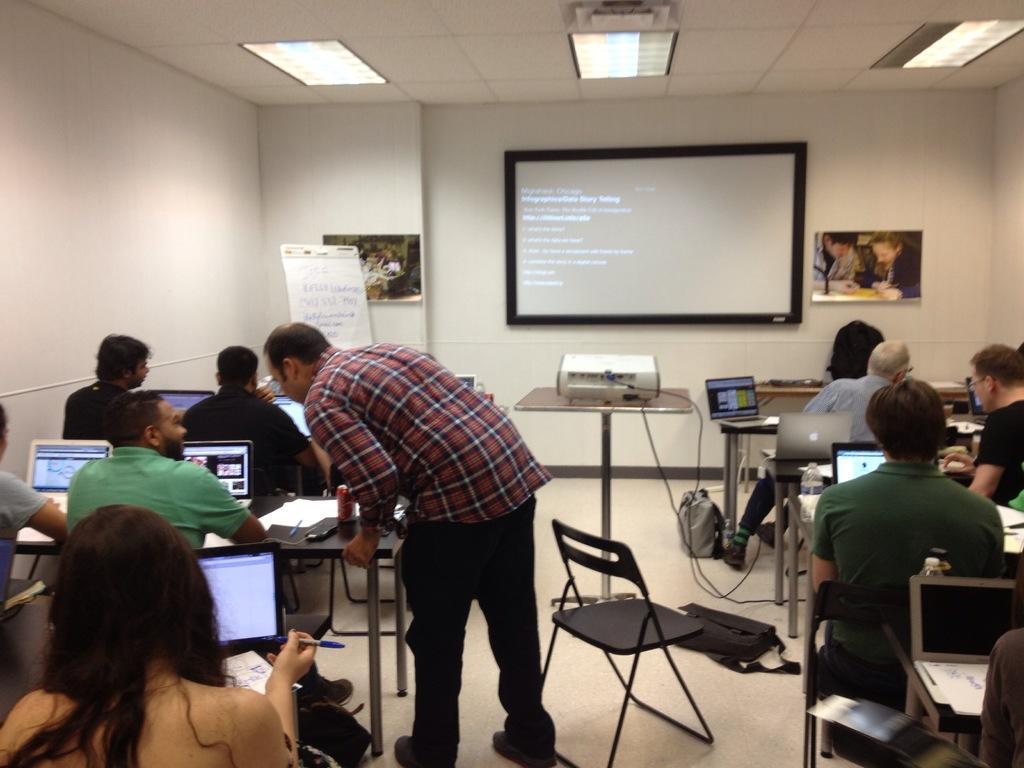How would you summarize this image in a sentence or two? In this image i can see a group of people sitting and doing work in front of a laptop here the man standing and talking to the other man, at the back ground i can see the projector, a table, a wall, at the top there is a light. 